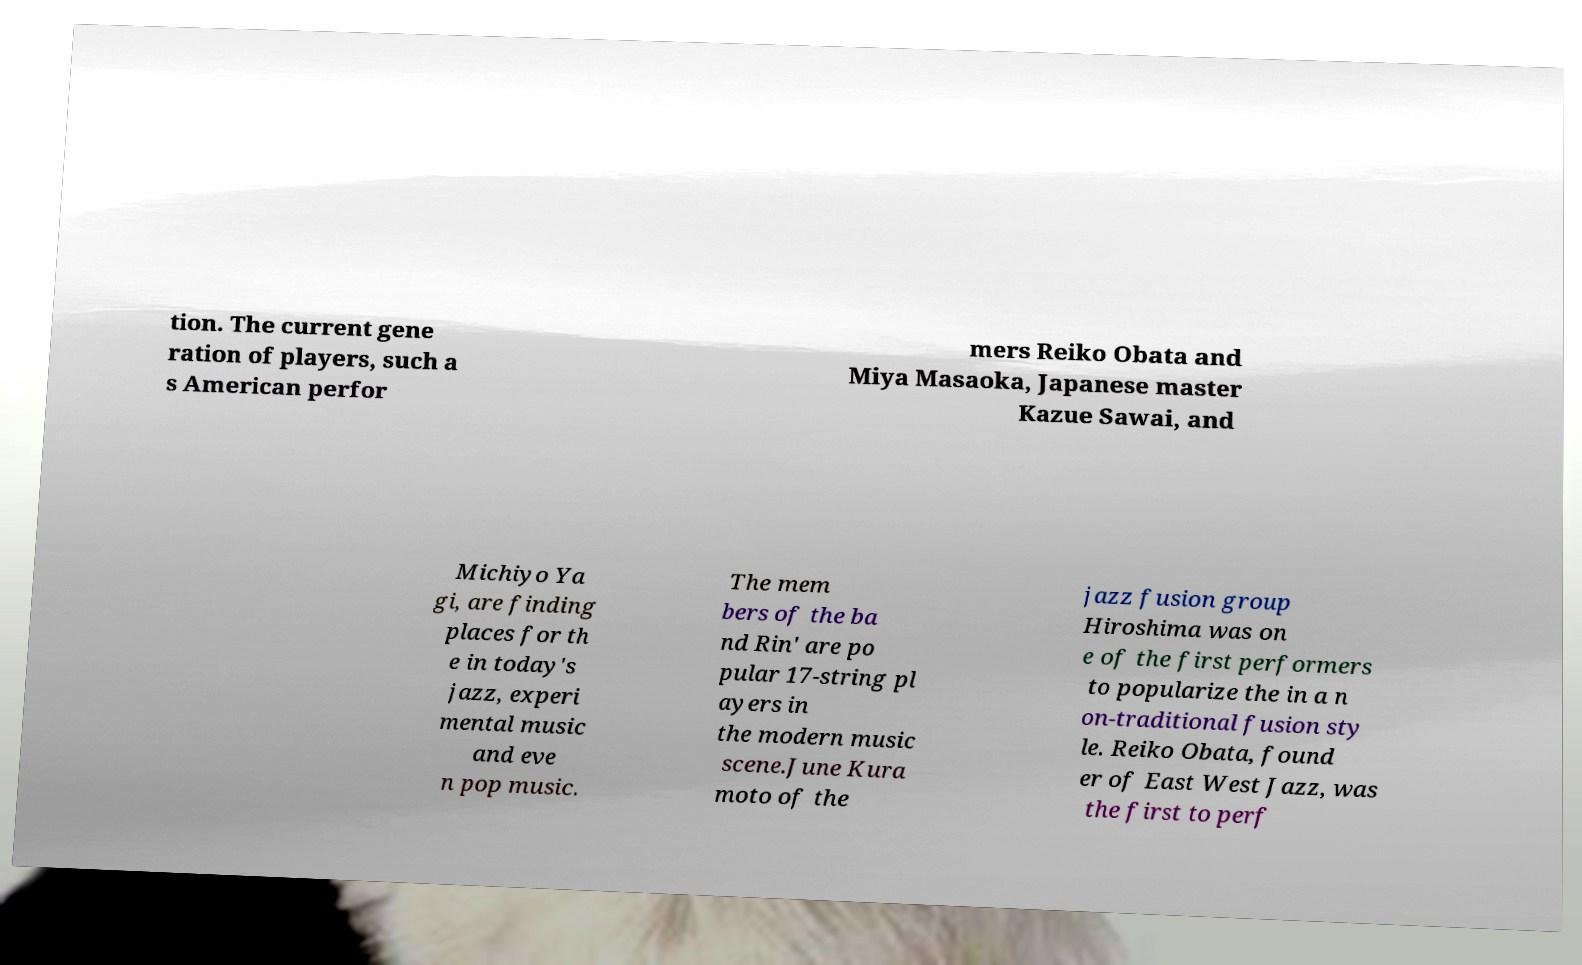Please read and relay the text visible in this image. What does it say? tion. The current gene ration of players, such a s American perfor mers Reiko Obata and Miya Masaoka, Japanese master Kazue Sawai, and Michiyo Ya gi, are finding places for th e in today's jazz, experi mental music and eve n pop music. The mem bers of the ba nd Rin' are po pular 17-string pl ayers in the modern music scene.June Kura moto of the jazz fusion group Hiroshima was on e of the first performers to popularize the in a n on-traditional fusion sty le. Reiko Obata, found er of East West Jazz, was the first to perf 